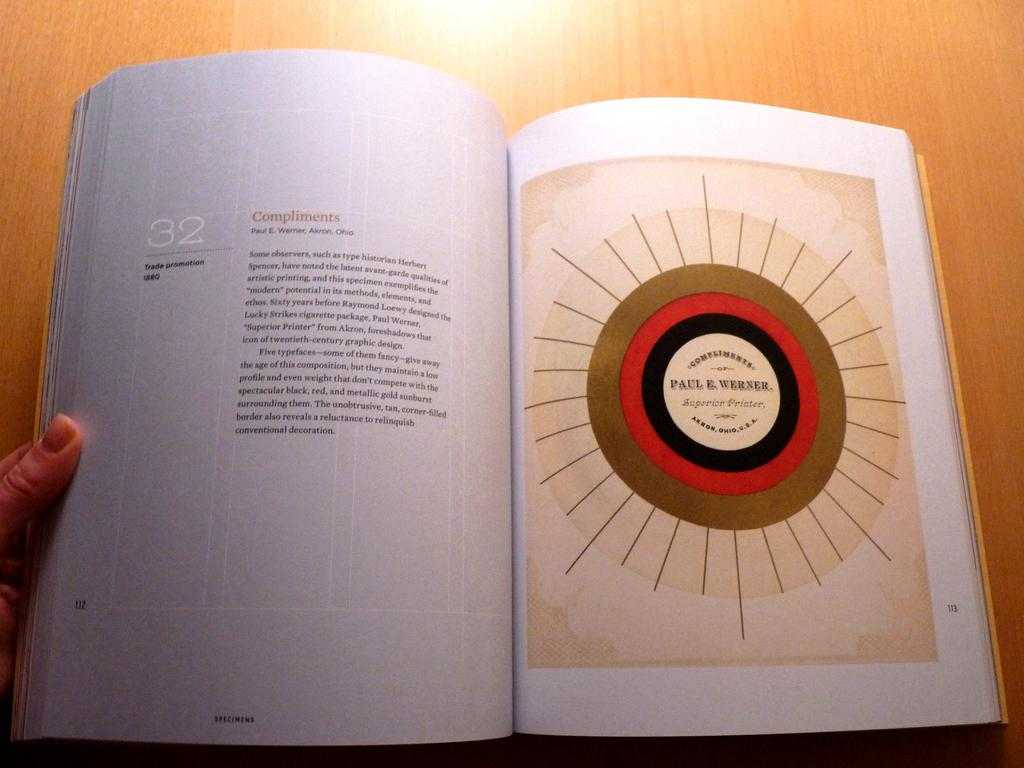Provide a one-sentence caption for the provided image. A book is opened to page 112 with "Compliments" at the top of the paragraph. 